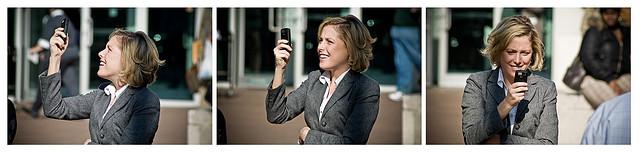What is the women holding?
Give a very brief answer. Cell phone. What is the color of the woman's hair?
Concise answer only. Blonde. Is this woman holding a phone?
Concise answer only. Yes. 